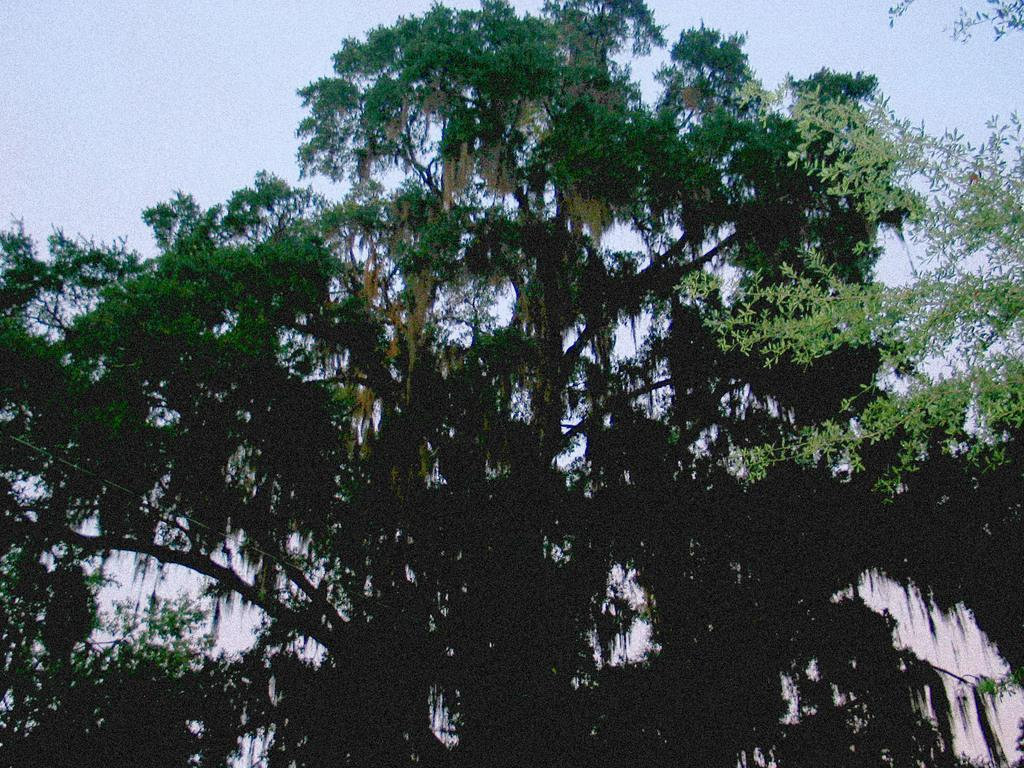What type of natural element is present in the image? There is a tree in the image. What can be seen in the background of the image? The sky is visible in the background of the image. What color is the cast on the tree in the image? There is no cast present on the tree in the image. 